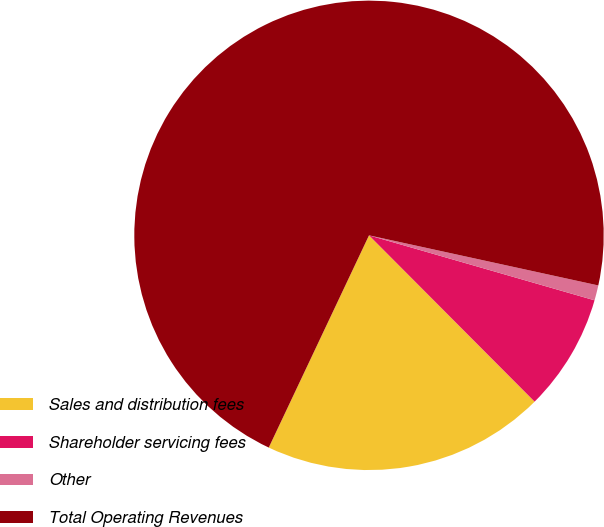<chart> <loc_0><loc_0><loc_500><loc_500><pie_chart><fcel>Sales and distribution fees<fcel>Shareholder servicing fees<fcel>Other<fcel>Total Operating Revenues<nl><fcel>19.49%<fcel>8.07%<fcel>1.04%<fcel>71.4%<nl></chart> 